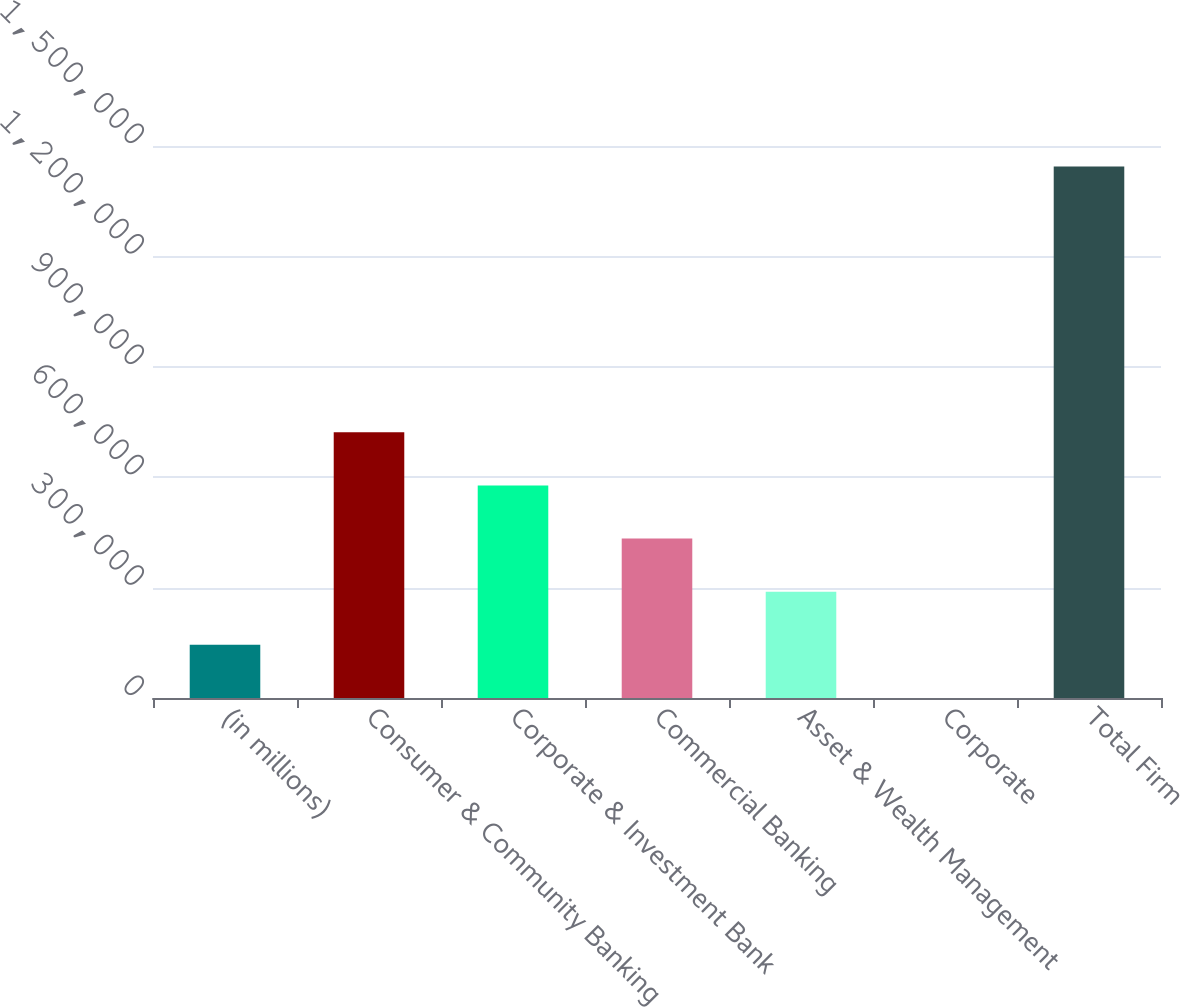Convert chart to OTSL. <chart><loc_0><loc_0><loc_500><loc_500><bar_chart><fcel>(in millions)<fcel>Consumer & Community Banking<fcel>Corporate & Investment Bank<fcel>Commercial Banking<fcel>Asset & Wealth Management<fcel>Corporate<fcel>Total Firm<nl><fcel>144664<fcel>722138<fcel>577770<fcel>433401<fcel>289032<fcel>295<fcel>1.44398e+06<nl></chart> 